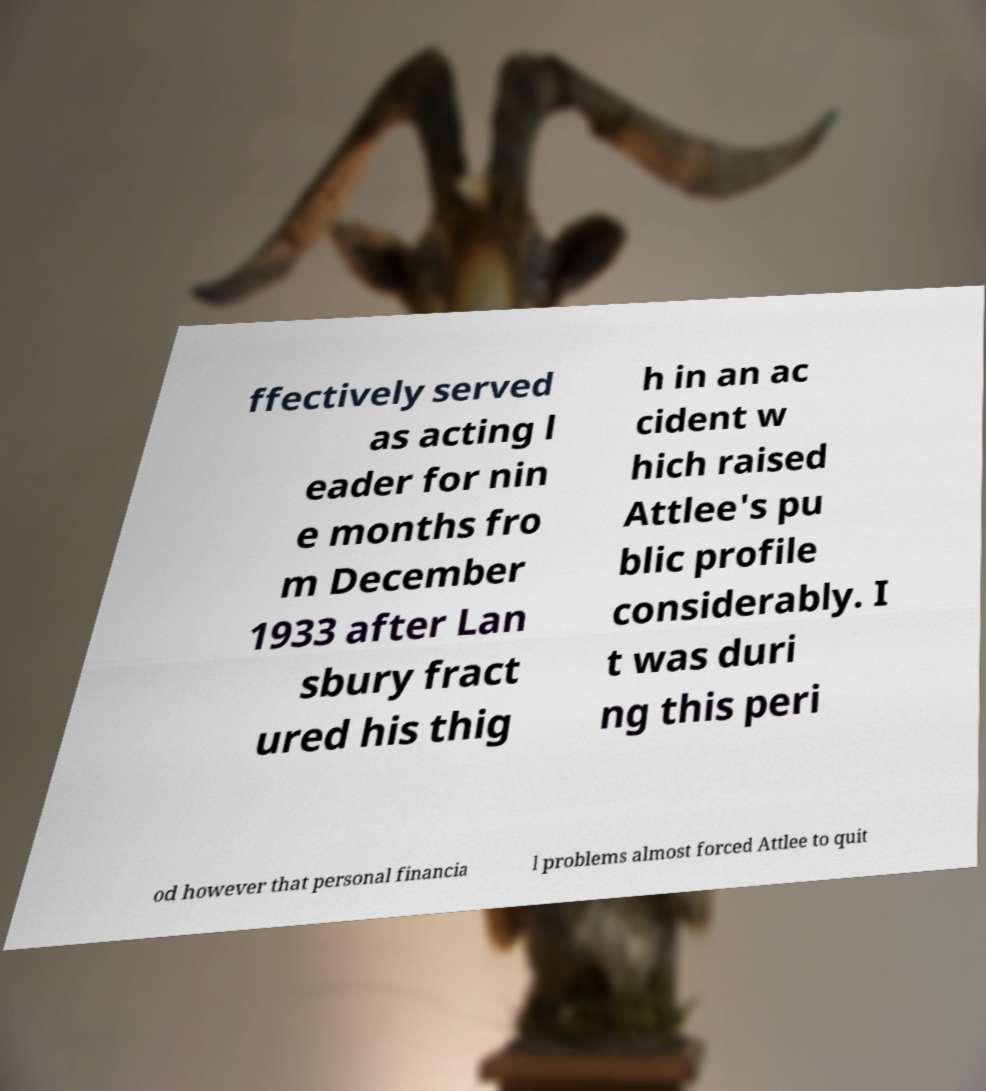Can you accurately transcribe the text from the provided image for me? ffectively served as acting l eader for nin e months fro m December 1933 after Lan sbury fract ured his thig h in an ac cident w hich raised Attlee's pu blic profile considerably. I t was duri ng this peri od however that personal financia l problems almost forced Attlee to quit 